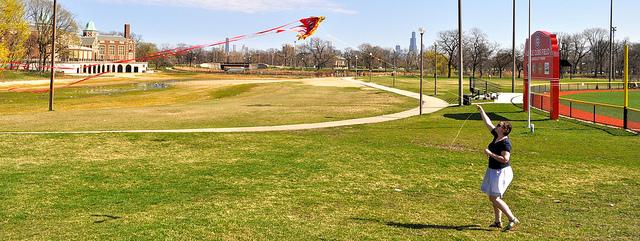Is the grass extremely green?
Answer briefly. No. What kind of field is this man flying a kite on?
Answer briefly. Baseball. What is the woman doing?
Write a very short answer. Flying kite. 